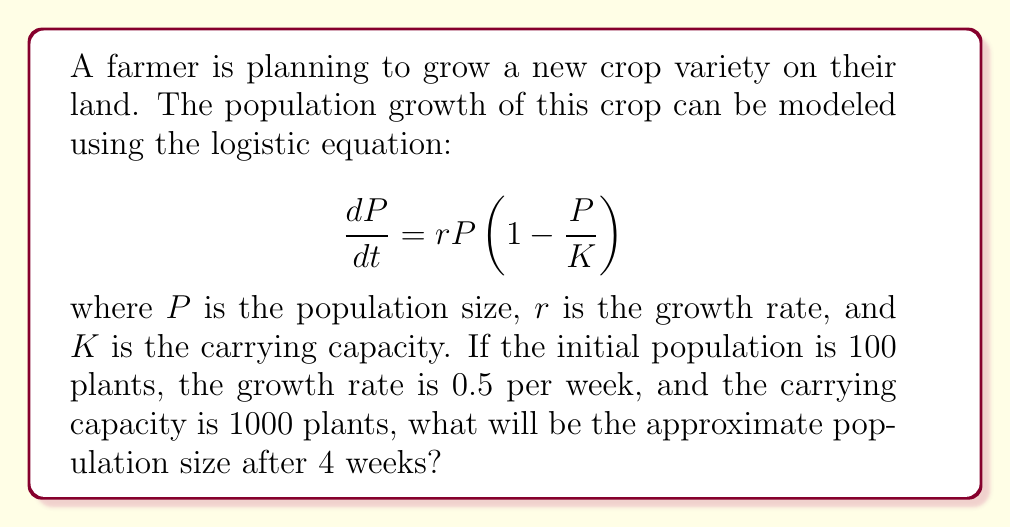Help me with this question. To solve this problem, we'll use the solution to the logistic equation:

$$P(t) = \frac{K}{1 + (\frac{K}{P_0} - 1)e^{-rt}}$$

Where:
$P(t)$ is the population at time $t$
$K$ is the carrying capacity (1000 plants)
$P_0$ is the initial population (100 plants)
$r$ is the growth rate (0.5 per week)
$t$ is the time (4 weeks)

Let's plug in the values:

$$P(4) = \frac{1000}{1 + (\frac{1000}{100} - 1)e^{-0.5 * 4}}$$

$$= \frac{1000}{1 + 9e^{-2}}$$

$$= \frac{1000}{1 + 9 * 0.1353}$$

$$= \frac{1000}{2.2177}$$

$$\approx 450.92$$

Therefore, after 4 weeks, the population will be approximately 451 plants (rounded to the nearest whole number).
Answer: 451 plants 